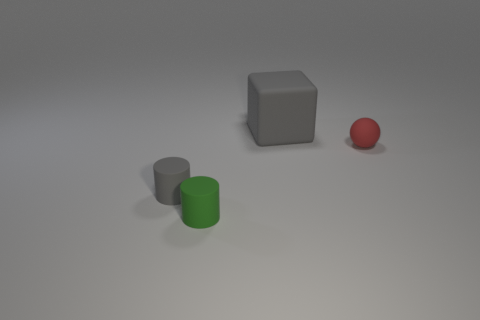What material is the other small object that is the same shape as the tiny gray object?
Offer a very short reply. Rubber. Is there anything else that is the same size as the gray block?
Your answer should be very brief. No. Are any red rubber balls visible?
Give a very brief answer. Yes. What material is the object that is behind the small rubber object behind the gray object on the left side of the tiny green rubber object made of?
Your answer should be compact. Rubber. There is a large thing; is it the same shape as the gray matte object on the left side of the green object?
Keep it short and to the point. No. How many green rubber objects have the same shape as the red rubber thing?
Provide a succinct answer. 0. The small gray rubber object is what shape?
Offer a very short reply. Cylinder. What size is the gray object that is on the left side of the gray matte thing that is behind the red thing?
Provide a succinct answer. Small. How many things are small green rubber cylinders or large gray matte things?
Offer a very short reply. 2. Is the small gray rubber object the same shape as the big gray object?
Offer a terse response. No. 